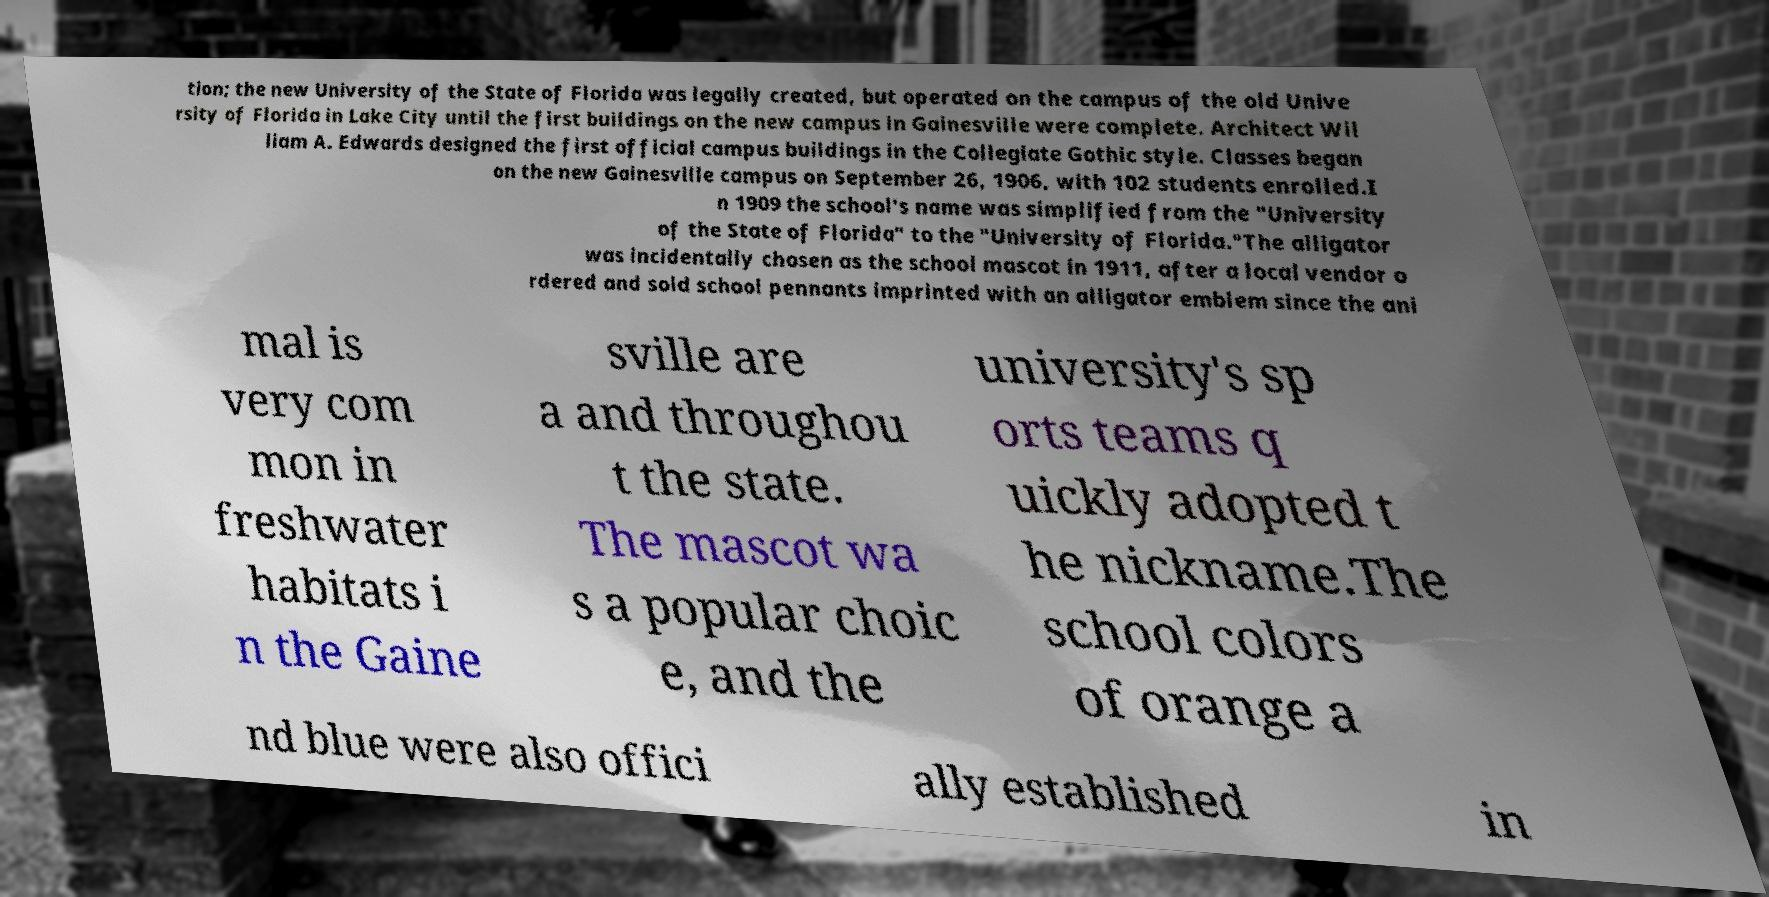Please identify and transcribe the text found in this image. tion; the new University of the State of Florida was legally created, but operated on the campus of the old Unive rsity of Florida in Lake City until the first buildings on the new campus in Gainesville were complete. Architect Wil liam A. Edwards designed the first official campus buildings in the Collegiate Gothic style. Classes began on the new Gainesville campus on September 26, 1906, with 102 students enrolled.I n 1909 the school's name was simplified from the "University of the State of Florida" to the "University of Florida."The alligator was incidentally chosen as the school mascot in 1911, after a local vendor o rdered and sold school pennants imprinted with an alligator emblem since the ani mal is very com mon in freshwater habitats i n the Gaine sville are a and throughou t the state. The mascot wa s a popular choic e, and the university's sp orts teams q uickly adopted t he nickname.The school colors of orange a nd blue were also offici ally established in 